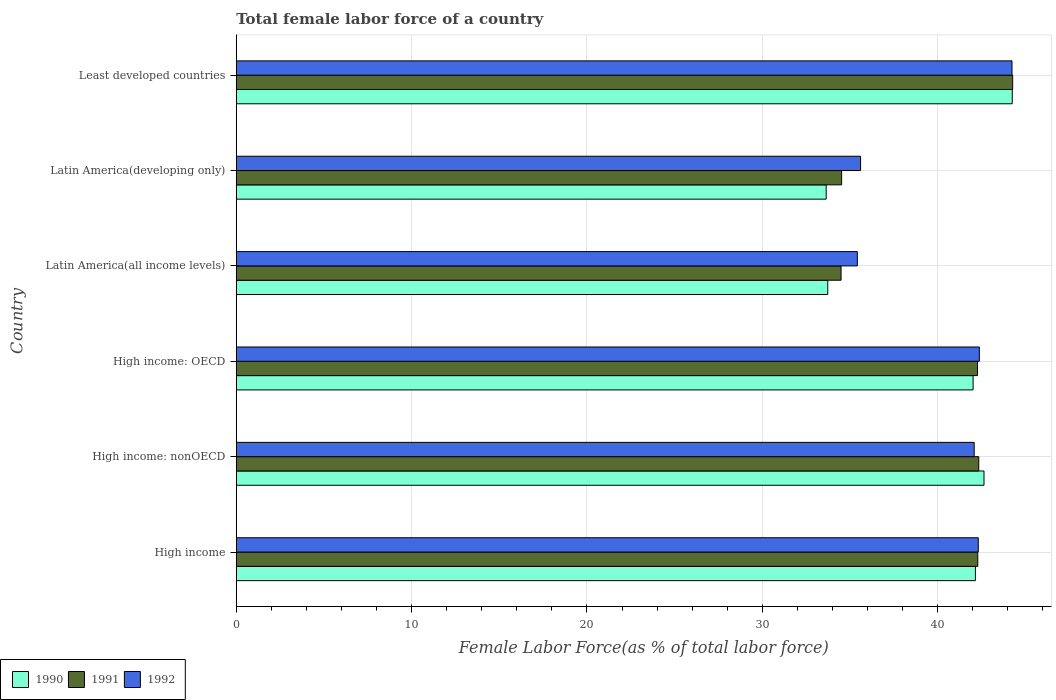Are the number of bars per tick equal to the number of legend labels?
Offer a terse response. Yes. Are the number of bars on each tick of the Y-axis equal?
Give a very brief answer. Yes. How many bars are there on the 6th tick from the top?
Your answer should be compact. 3. How many bars are there on the 6th tick from the bottom?
Make the answer very short. 3. What is the label of the 2nd group of bars from the top?
Keep it short and to the point. Latin America(developing only). In how many cases, is the number of bars for a given country not equal to the number of legend labels?
Give a very brief answer. 0. What is the percentage of female labor force in 1990 in Latin America(all income levels)?
Your response must be concise. 33.73. Across all countries, what is the maximum percentage of female labor force in 1992?
Offer a terse response. 44.24. Across all countries, what is the minimum percentage of female labor force in 1990?
Provide a short and direct response. 33.64. In which country was the percentage of female labor force in 1992 maximum?
Provide a succinct answer. Least developed countries. In which country was the percentage of female labor force in 1992 minimum?
Keep it short and to the point. Latin America(all income levels). What is the total percentage of female labor force in 1992 in the graph?
Your answer should be very brief. 242.04. What is the difference between the percentage of female labor force in 1992 in High income: nonOECD and that in Latin America(all income levels)?
Give a very brief answer. 6.66. What is the difference between the percentage of female labor force in 1992 in Latin America(developing only) and the percentage of female labor force in 1991 in Least developed countries?
Your response must be concise. -8.67. What is the average percentage of female labor force in 1990 per country?
Give a very brief answer. 39.74. What is the difference between the percentage of female labor force in 1992 and percentage of female labor force in 1991 in High income: OECD?
Keep it short and to the point. 0.11. In how many countries, is the percentage of female labor force in 1991 greater than 16 %?
Offer a terse response. 6. What is the ratio of the percentage of female labor force in 1992 in High income to that in Least developed countries?
Your answer should be very brief. 0.96. Is the percentage of female labor force in 1990 in High income: OECD less than that in Least developed countries?
Offer a very short reply. Yes. Is the difference between the percentage of female labor force in 1992 in High income: nonOECD and Latin America(developing only) greater than the difference between the percentage of female labor force in 1991 in High income: nonOECD and Latin America(developing only)?
Make the answer very short. No. What is the difference between the highest and the second highest percentage of female labor force in 1992?
Offer a terse response. 1.86. What is the difference between the highest and the lowest percentage of female labor force in 1991?
Offer a terse response. 9.79. What does the 1st bar from the top in High income: nonOECD represents?
Give a very brief answer. 1992. Is it the case that in every country, the sum of the percentage of female labor force in 1992 and percentage of female labor force in 1990 is greater than the percentage of female labor force in 1991?
Make the answer very short. Yes. Are all the bars in the graph horizontal?
Offer a terse response. Yes. How many countries are there in the graph?
Ensure brevity in your answer.  6. What is the difference between two consecutive major ticks on the X-axis?
Offer a terse response. 10. Are the values on the major ticks of X-axis written in scientific E-notation?
Your response must be concise. No. Does the graph contain any zero values?
Your answer should be very brief. No. How are the legend labels stacked?
Your answer should be compact. Horizontal. What is the title of the graph?
Ensure brevity in your answer.  Total female labor force of a country. Does "1972" appear as one of the legend labels in the graph?
Offer a very short reply. No. What is the label or title of the X-axis?
Your answer should be compact. Female Labor Force(as % of total labor force). What is the Female Labor Force(as % of total labor force) of 1990 in High income?
Your response must be concise. 42.15. What is the Female Labor Force(as % of total labor force) in 1991 in High income?
Make the answer very short. 42.29. What is the Female Labor Force(as % of total labor force) of 1992 in High income?
Offer a very short reply. 42.32. What is the Female Labor Force(as % of total labor force) in 1990 in High income: nonOECD?
Offer a very short reply. 42.64. What is the Female Labor Force(as % of total labor force) in 1991 in High income: nonOECD?
Make the answer very short. 42.34. What is the Female Labor Force(as % of total labor force) of 1992 in High income: nonOECD?
Ensure brevity in your answer.  42.08. What is the Female Labor Force(as % of total labor force) of 1990 in High income: OECD?
Your response must be concise. 42.02. What is the Female Labor Force(as % of total labor force) in 1991 in High income: OECD?
Your answer should be compact. 42.27. What is the Female Labor Force(as % of total labor force) of 1992 in High income: OECD?
Make the answer very short. 42.38. What is the Female Labor Force(as % of total labor force) in 1990 in Latin America(all income levels)?
Provide a short and direct response. 33.73. What is the Female Labor Force(as % of total labor force) in 1991 in Latin America(all income levels)?
Keep it short and to the point. 34.49. What is the Female Labor Force(as % of total labor force) of 1992 in Latin America(all income levels)?
Provide a succinct answer. 35.42. What is the Female Labor Force(as % of total labor force) of 1990 in Latin America(developing only)?
Provide a succinct answer. 33.64. What is the Female Labor Force(as % of total labor force) of 1991 in Latin America(developing only)?
Provide a succinct answer. 34.52. What is the Female Labor Force(as % of total labor force) in 1992 in Latin America(developing only)?
Make the answer very short. 35.6. What is the Female Labor Force(as % of total labor force) of 1990 in Least developed countries?
Your response must be concise. 44.25. What is the Female Labor Force(as % of total labor force) of 1991 in Least developed countries?
Give a very brief answer. 44.28. What is the Female Labor Force(as % of total labor force) in 1992 in Least developed countries?
Your response must be concise. 44.24. Across all countries, what is the maximum Female Labor Force(as % of total labor force) in 1990?
Make the answer very short. 44.25. Across all countries, what is the maximum Female Labor Force(as % of total labor force) of 1991?
Provide a succinct answer. 44.28. Across all countries, what is the maximum Female Labor Force(as % of total labor force) in 1992?
Make the answer very short. 44.24. Across all countries, what is the minimum Female Labor Force(as % of total labor force) of 1990?
Ensure brevity in your answer.  33.64. Across all countries, what is the minimum Female Labor Force(as % of total labor force) in 1991?
Give a very brief answer. 34.49. Across all countries, what is the minimum Female Labor Force(as % of total labor force) of 1992?
Provide a succinct answer. 35.42. What is the total Female Labor Force(as % of total labor force) in 1990 in the graph?
Ensure brevity in your answer.  238.45. What is the total Female Labor Force(as % of total labor force) in 1991 in the graph?
Provide a short and direct response. 240.19. What is the total Female Labor Force(as % of total labor force) of 1992 in the graph?
Your answer should be compact. 242.04. What is the difference between the Female Labor Force(as % of total labor force) of 1990 in High income and that in High income: nonOECD?
Ensure brevity in your answer.  -0.49. What is the difference between the Female Labor Force(as % of total labor force) in 1991 in High income and that in High income: nonOECD?
Give a very brief answer. -0.06. What is the difference between the Female Labor Force(as % of total labor force) in 1992 in High income and that in High income: nonOECD?
Your answer should be very brief. 0.23. What is the difference between the Female Labor Force(as % of total labor force) in 1990 in High income and that in High income: OECD?
Your answer should be very brief. 0.13. What is the difference between the Female Labor Force(as % of total labor force) in 1991 in High income and that in High income: OECD?
Keep it short and to the point. 0.01. What is the difference between the Female Labor Force(as % of total labor force) in 1992 in High income and that in High income: OECD?
Provide a succinct answer. -0.06. What is the difference between the Female Labor Force(as % of total labor force) in 1990 in High income and that in Latin America(all income levels)?
Your response must be concise. 8.42. What is the difference between the Female Labor Force(as % of total labor force) in 1991 in High income and that in Latin America(all income levels)?
Offer a terse response. 7.8. What is the difference between the Female Labor Force(as % of total labor force) of 1992 in High income and that in Latin America(all income levels)?
Your response must be concise. 6.9. What is the difference between the Female Labor Force(as % of total labor force) in 1990 in High income and that in Latin America(developing only)?
Keep it short and to the point. 8.51. What is the difference between the Female Labor Force(as % of total labor force) of 1991 in High income and that in Latin America(developing only)?
Make the answer very short. 7.76. What is the difference between the Female Labor Force(as % of total labor force) in 1992 in High income and that in Latin America(developing only)?
Your answer should be compact. 6.71. What is the difference between the Female Labor Force(as % of total labor force) in 1990 in High income and that in Least developed countries?
Give a very brief answer. -2.1. What is the difference between the Female Labor Force(as % of total labor force) in 1991 in High income and that in Least developed countries?
Offer a terse response. -1.99. What is the difference between the Female Labor Force(as % of total labor force) in 1992 in High income and that in Least developed countries?
Provide a succinct answer. -1.92. What is the difference between the Female Labor Force(as % of total labor force) in 1990 in High income: nonOECD and that in High income: OECD?
Your answer should be compact. 0.62. What is the difference between the Female Labor Force(as % of total labor force) in 1991 in High income: nonOECD and that in High income: OECD?
Keep it short and to the point. 0.07. What is the difference between the Female Labor Force(as % of total labor force) in 1992 in High income: nonOECD and that in High income: OECD?
Your answer should be compact. -0.29. What is the difference between the Female Labor Force(as % of total labor force) of 1990 in High income: nonOECD and that in Latin America(all income levels)?
Keep it short and to the point. 8.91. What is the difference between the Female Labor Force(as % of total labor force) in 1991 in High income: nonOECD and that in Latin America(all income levels)?
Your answer should be compact. 7.85. What is the difference between the Female Labor Force(as % of total labor force) in 1992 in High income: nonOECD and that in Latin America(all income levels)?
Your response must be concise. 6.66. What is the difference between the Female Labor Force(as % of total labor force) of 1990 in High income: nonOECD and that in Latin America(developing only)?
Your response must be concise. 9. What is the difference between the Female Labor Force(as % of total labor force) of 1991 in High income: nonOECD and that in Latin America(developing only)?
Keep it short and to the point. 7.82. What is the difference between the Female Labor Force(as % of total labor force) in 1992 in High income: nonOECD and that in Latin America(developing only)?
Offer a terse response. 6.48. What is the difference between the Female Labor Force(as % of total labor force) of 1990 in High income: nonOECD and that in Least developed countries?
Provide a succinct answer. -1.61. What is the difference between the Female Labor Force(as % of total labor force) in 1991 in High income: nonOECD and that in Least developed countries?
Your answer should be compact. -1.94. What is the difference between the Female Labor Force(as % of total labor force) in 1992 in High income: nonOECD and that in Least developed countries?
Your answer should be compact. -2.16. What is the difference between the Female Labor Force(as % of total labor force) of 1990 in High income: OECD and that in Latin America(all income levels)?
Offer a very short reply. 8.29. What is the difference between the Female Labor Force(as % of total labor force) of 1991 in High income: OECD and that in Latin America(all income levels)?
Your answer should be very brief. 7.78. What is the difference between the Female Labor Force(as % of total labor force) in 1992 in High income: OECD and that in Latin America(all income levels)?
Give a very brief answer. 6.96. What is the difference between the Female Labor Force(as % of total labor force) in 1990 in High income: OECD and that in Latin America(developing only)?
Provide a short and direct response. 8.38. What is the difference between the Female Labor Force(as % of total labor force) in 1991 in High income: OECD and that in Latin America(developing only)?
Ensure brevity in your answer.  7.75. What is the difference between the Female Labor Force(as % of total labor force) in 1992 in High income: OECD and that in Latin America(developing only)?
Keep it short and to the point. 6.77. What is the difference between the Female Labor Force(as % of total labor force) of 1990 in High income: OECD and that in Least developed countries?
Provide a short and direct response. -2.23. What is the difference between the Female Labor Force(as % of total labor force) in 1991 in High income: OECD and that in Least developed countries?
Provide a succinct answer. -2.01. What is the difference between the Female Labor Force(as % of total labor force) in 1992 in High income: OECD and that in Least developed countries?
Keep it short and to the point. -1.86. What is the difference between the Female Labor Force(as % of total labor force) in 1990 in Latin America(all income levels) and that in Latin America(developing only)?
Make the answer very short. 0.09. What is the difference between the Female Labor Force(as % of total labor force) in 1991 in Latin America(all income levels) and that in Latin America(developing only)?
Offer a very short reply. -0.03. What is the difference between the Female Labor Force(as % of total labor force) in 1992 in Latin America(all income levels) and that in Latin America(developing only)?
Your answer should be compact. -0.18. What is the difference between the Female Labor Force(as % of total labor force) in 1990 in Latin America(all income levels) and that in Least developed countries?
Your response must be concise. -10.52. What is the difference between the Female Labor Force(as % of total labor force) in 1991 in Latin America(all income levels) and that in Least developed countries?
Keep it short and to the point. -9.79. What is the difference between the Female Labor Force(as % of total labor force) of 1992 in Latin America(all income levels) and that in Least developed countries?
Your answer should be very brief. -8.82. What is the difference between the Female Labor Force(as % of total labor force) of 1990 in Latin America(developing only) and that in Least developed countries?
Offer a very short reply. -10.61. What is the difference between the Female Labor Force(as % of total labor force) in 1991 in Latin America(developing only) and that in Least developed countries?
Keep it short and to the point. -9.75. What is the difference between the Female Labor Force(as % of total labor force) in 1992 in Latin America(developing only) and that in Least developed countries?
Your response must be concise. -8.63. What is the difference between the Female Labor Force(as % of total labor force) of 1990 in High income and the Female Labor Force(as % of total labor force) of 1991 in High income: nonOECD?
Offer a terse response. -0.19. What is the difference between the Female Labor Force(as % of total labor force) in 1990 in High income and the Female Labor Force(as % of total labor force) in 1992 in High income: nonOECD?
Your answer should be compact. 0.07. What is the difference between the Female Labor Force(as % of total labor force) in 1991 in High income and the Female Labor Force(as % of total labor force) in 1992 in High income: nonOECD?
Keep it short and to the point. 0.2. What is the difference between the Female Labor Force(as % of total labor force) of 1990 in High income and the Female Labor Force(as % of total labor force) of 1991 in High income: OECD?
Provide a succinct answer. -0.12. What is the difference between the Female Labor Force(as % of total labor force) in 1990 in High income and the Female Labor Force(as % of total labor force) in 1992 in High income: OECD?
Keep it short and to the point. -0.23. What is the difference between the Female Labor Force(as % of total labor force) in 1991 in High income and the Female Labor Force(as % of total labor force) in 1992 in High income: OECD?
Offer a very short reply. -0.09. What is the difference between the Female Labor Force(as % of total labor force) in 1990 in High income and the Female Labor Force(as % of total labor force) in 1991 in Latin America(all income levels)?
Your response must be concise. 7.66. What is the difference between the Female Labor Force(as % of total labor force) in 1990 in High income and the Female Labor Force(as % of total labor force) in 1992 in Latin America(all income levels)?
Give a very brief answer. 6.73. What is the difference between the Female Labor Force(as % of total labor force) in 1991 in High income and the Female Labor Force(as % of total labor force) in 1992 in Latin America(all income levels)?
Provide a succinct answer. 6.87. What is the difference between the Female Labor Force(as % of total labor force) of 1990 in High income and the Female Labor Force(as % of total labor force) of 1991 in Latin America(developing only)?
Make the answer very short. 7.63. What is the difference between the Female Labor Force(as % of total labor force) of 1990 in High income and the Female Labor Force(as % of total labor force) of 1992 in Latin America(developing only)?
Keep it short and to the point. 6.55. What is the difference between the Female Labor Force(as % of total labor force) of 1991 in High income and the Female Labor Force(as % of total labor force) of 1992 in Latin America(developing only)?
Keep it short and to the point. 6.68. What is the difference between the Female Labor Force(as % of total labor force) in 1990 in High income and the Female Labor Force(as % of total labor force) in 1991 in Least developed countries?
Keep it short and to the point. -2.13. What is the difference between the Female Labor Force(as % of total labor force) of 1990 in High income and the Female Labor Force(as % of total labor force) of 1992 in Least developed countries?
Your answer should be very brief. -2.09. What is the difference between the Female Labor Force(as % of total labor force) in 1991 in High income and the Female Labor Force(as % of total labor force) in 1992 in Least developed countries?
Your answer should be compact. -1.95. What is the difference between the Female Labor Force(as % of total labor force) in 1990 in High income: nonOECD and the Female Labor Force(as % of total labor force) in 1991 in High income: OECD?
Give a very brief answer. 0.37. What is the difference between the Female Labor Force(as % of total labor force) in 1990 in High income: nonOECD and the Female Labor Force(as % of total labor force) in 1992 in High income: OECD?
Provide a short and direct response. 0.27. What is the difference between the Female Labor Force(as % of total labor force) in 1991 in High income: nonOECD and the Female Labor Force(as % of total labor force) in 1992 in High income: OECD?
Ensure brevity in your answer.  -0.04. What is the difference between the Female Labor Force(as % of total labor force) of 1990 in High income: nonOECD and the Female Labor Force(as % of total labor force) of 1991 in Latin America(all income levels)?
Your answer should be compact. 8.15. What is the difference between the Female Labor Force(as % of total labor force) of 1990 in High income: nonOECD and the Female Labor Force(as % of total labor force) of 1992 in Latin America(all income levels)?
Keep it short and to the point. 7.22. What is the difference between the Female Labor Force(as % of total labor force) of 1991 in High income: nonOECD and the Female Labor Force(as % of total labor force) of 1992 in Latin America(all income levels)?
Your answer should be compact. 6.92. What is the difference between the Female Labor Force(as % of total labor force) of 1990 in High income: nonOECD and the Female Labor Force(as % of total labor force) of 1991 in Latin America(developing only)?
Your answer should be compact. 8.12. What is the difference between the Female Labor Force(as % of total labor force) of 1990 in High income: nonOECD and the Female Labor Force(as % of total labor force) of 1992 in Latin America(developing only)?
Offer a terse response. 7.04. What is the difference between the Female Labor Force(as % of total labor force) in 1991 in High income: nonOECD and the Female Labor Force(as % of total labor force) in 1992 in Latin America(developing only)?
Your answer should be compact. 6.74. What is the difference between the Female Labor Force(as % of total labor force) in 1990 in High income: nonOECD and the Female Labor Force(as % of total labor force) in 1991 in Least developed countries?
Keep it short and to the point. -1.63. What is the difference between the Female Labor Force(as % of total labor force) of 1990 in High income: nonOECD and the Female Labor Force(as % of total labor force) of 1992 in Least developed countries?
Your answer should be very brief. -1.6. What is the difference between the Female Labor Force(as % of total labor force) of 1991 in High income: nonOECD and the Female Labor Force(as % of total labor force) of 1992 in Least developed countries?
Your answer should be compact. -1.9. What is the difference between the Female Labor Force(as % of total labor force) in 1990 in High income: OECD and the Female Labor Force(as % of total labor force) in 1991 in Latin America(all income levels)?
Your response must be concise. 7.53. What is the difference between the Female Labor Force(as % of total labor force) in 1990 in High income: OECD and the Female Labor Force(as % of total labor force) in 1992 in Latin America(all income levels)?
Your answer should be very brief. 6.6. What is the difference between the Female Labor Force(as % of total labor force) of 1991 in High income: OECD and the Female Labor Force(as % of total labor force) of 1992 in Latin America(all income levels)?
Your answer should be very brief. 6.85. What is the difference between the Female Labor Force(as % of total labor force) of 1990 in High income: OECD and the Female Labor Force(as % of total labor force) of 1991 in Latin America(developing only)?
Offer a terse response. 7.5. What is the difference between the Female Labor Force(as % of total labor force) in 1990 in High income: OECD and the Female Labor Force(as % of total labor force) in 1992 in Latin America(developing only)?
Your answer should be compact. 6.42. What is the difference between the Female Labor Force(as % of total labor force) in 1991 in High income: OECD and the Female Labor Force(as % of total labor force) in 1992 in Latin America(developing only)?
Offer a terse response. 6.67. What is the difference between the Female Labor Force(as % of total labor force) in 1990 in High income: OECD and the Female Labor Force(as % of total labor force) in 1991 in Least developed countries?
Offer a very short reply. -2.26. What is the difference between the Female Labor Force(as % of total labor force) of 1990 in High income: OECD and the Female Labor Force(as % of total labor force) of 1992 in Least developed countries?
Keep it short and to the point. -2.22. What is the difference between the Female Labor Force(as % of total labor force) in 1991 in High income: OECD and the Female Labor Force(as % of total labor force) in 1992 in Least developed countries?
Provide a short and direct response. -1.97. What is the difference between the Female Labor Force(as % of total labor force) in 1990 in Latin America(all income levels) and the Female Labor Force(as % of total labor force) in 1991 in Latin America(developing only)?
Offer a terse response. -0.79. What is the difference between the Female Labor Force(as % of total labor force) in 1990 in Latin America(all income levels) and the Female Labor Force(as % of total labor force) in 1992 in Latin America(developing only)?
Provide a succinct answer. -1.87. What is the difference between the Female Labor Force(as % of total labor force) of 1991 in Latin America(all income levels) and the Female Labor Force(as % of total labor force) of 1992 in Latin America(developing only)?
Offer a very short reply. -1.11. What is the difference between the Female Labor Force(as % of total labor force) of 1990 in Latin America(all income levels) and the Female Labor Force(as % of total labor force) of 1991 in Least developed countries?
Your answer should be very brief. -10.55. What is the difference between the Female Labor Force(as % of total labor force) of 1990 in Latin America(all income levels) and the Female Labor Force(as % of total labor force) of 1992 in Least developed countries?
Give a very brief answer. -10.51. What is the difference between the Female Labor Force(as % of total labor force) in 1991 in Latin America(all income levels) and the Female Labor Force(as % of total labor force) in 1992 in Least developed countries?
Offer a terse response. -9.75. What is the difference between the Female Labor Force(as % of total labor force) in 1990 in Latin America(developing only) and the Female Labor Force(as % of total labor force) in 1991 in Least developed countries?
Provide a short and direct response. -10.63. What is the difference between the Female Labor Force(as % of total labor force) of 1990 in Latin America(developing only) and the Female Labor Force(as % of total labor force) of 1992 in Least developed countries?
Keep it short and to the point. -10.6. What is the difference between the Female Labor Force(as % of total labor force) in 1991 in Latin America(developing only) and the Female Labor Force(as % of total labor force) in 1992 in Least developed countries?
Your answer should be compact. -9.72. What is the average Female Labor Force(as % of total labor force) in 1990 per country?
Offer a very short reply. 39.74. What is the average Female Labor Force(as % of total labor force) of 1991 per country?
Provide a short and direct response. 40.03. What is the average Female Labor Force(as % of total labor force) of 1992 per country?
Provide a succinct answer. 40.34. What is the difference between the Female Labor Force(as % of total labor force) in 1990 and Female Labor Force(as % of total labor force) in 1991 in High income?
Your answer should be very brief. -0.13. What is the difference between the Female Labor Force(as % of total labor force) of 1990 and Female Labor Force(as % of total labor force) of 1992 in High income?
Offer a very short reply. -0.16. What is the difference between the Female Labor Force(as % of total labor force) in 1991 and Female Labor Force(as % of total labor force) in 1992 in High income?
Provide a short and direct response. -0.03. What is the difference between the Female Labor Force(as % of total labor force) of 1990 and Female Labor Force(as % of total labor force) of 1991 in High income: nonOECD?
Provide a short and direct response. 0.3. What is the difference between the Female Labor Force(as % of total labor force) of 1990 and Female Labor Force(as % of total labor force) of 1992 in High income: nonOECD?
Make the answer very short. 0.56. What is the difference between the Female Labor Force(as % of total labor force) of 1991 and Female Labor Force(as % of total labor force) of 1992 in High income: nonOECD?
Provide a short and direct response. 0.26. What is the difference between the Female Labor Force(as % of total labor force) in 1990 and Female Labor Force(as % of total labor force) in 1991 in High income: OECD?
Make the answer very short. -0.25. What is the difference between the Female Labor Force(as % of total labor force) of 1990 and Female Labor Force(as % of total labor force) of 1992 in High income: OECD?
Offer a very short reply. -0.36. What is the difference between the Female Labor Force(as % of total labor force) in 1991 and Female Labor Force(as % of total labor force) in 1992 in High income: OECD?
Offer a terse response. -0.11. What is the difference between the Female Labor Force(as % of total labor force) of 1990 and Female Labor Force(as % of total labor force) of 1991 in Latin America(all income levels)?
Ensure brevity in your answer.  -0.76. What is the difference between the Female Labor Force(as % of total labor force) in 1990 and Female Labor Force(as % of total labor force) in 1992 in Latin America(all income levels)?
Your answer should be very brief. -1.69. What is the difference between the Female Labor Force(as % of total labor force) of 1991 and Female Labor Force(as % of total labor force) of 1992 in Latin America(all income levels)?
Make the answer very short. -0.93. What is the difference between the Female Labor Force(as % of total labor force) of 1990 and Female Labor Force(as % of total labor force) of 1991 in Latin America(developing only)?
Make the answer very short. -0.88. What is the difference between the Female Labor Force(as % of total labor force) of 1990 and Female Labor Force(as % of total labor force) of 1992 in Latin America(developing only)?
Make the answer very short. -1.96. What is the difference between the Female Labor Force(as % of total labor force) in 1991 and Female Labor Force(as % of total labor force) in 1992 in Latin America(developing only)?
Keep it short and to the point. -1.08. What is the difference between the Female Labor Force(as % of total labor force) of 1990 and Female Labor Force(as % of total labor force) of 1991 in Least developed countries?
Offer a very short reply. -0.02. What is the difference between the Female Labor Force(as % of total labor force) of 1990 and Female Labor Force(as % of total labor force) of 1992 in Least developed countries?
Provide a short and direct response. 0.01. What is the difference between the Female Labor Force(as % of total labor force) of 1991 and Female Labor Force(as % of total labor force) of 1992 in Least developed countries?
Your answer should be compact. 0.04. What is the ratio of the Female Labor Force(as % of total labor force) of 1990 in High income to that in High income: nonOECD?
Offer a terse response. 0.99. What is the ratio of the Female Labor Force(as % of total labor force) in 1992 in High income to that in High income: nonOECD?
Offer a terse response. 1.01. What is the ratio of the Female Labor Force(as % of total labor force) of 1990 in High income to that in High income: OECD?
Your response must be concise. 1. What is the ratio of the Female Labor Force(as % of total labor force) in 1990 in High income to that in Latin America(all income levels)?
Your answer should be very brief. 1.25. What is the ratio of the Female Labor Force(as % of total labor force) in 1991 in High income to that in Latin America(all income levels)?
Your answer should be compact. 1.23. What is the ratio of the Female Labor Force(as % of total labor force) of 1992 in High income to that in Latin America(all income levels)?
Ensure brevity in your answer.  1.19. What is the ratio of the Female Labor Force(as % of total labor force) in 1990 in High income to that in Latin America(developing only)?
Provide a succinct answer. 1.25. What is the ratio of the Female Labor Force(as % of total labor force) of 1991 in High income to that in Latin America(developing only)?
Offer a terse response. 1.22. What is the ratio of the Female Labor Force(as % of total labor force) of 1992 in High income to that in Latin America(developing only)?
Your response must be concise. 1.19. What is the ratio of the Female Labor Force(as % of total labor force) of 1990 in High income to that in Least developed countries?
Ensure brevity in your answer.  0.95. What is the ratio of the Female Labor Force(as % of total labor force) in 1991 in High income to that in Least developed countries?
Your response must be concise. 0.95. What is the ratio of the Female Labor Force(as % of total labor force) of 1992 in High income to that in Least developed countries?
Make the answer very short. 0.96. What is the ratio of the Female Labor Force(as % of total labor force) in 1990 in High income: nonOECD to that in High income: OECD?
Ensure brevity in your answer.  1.01. What is the ratio of the Female Labor Force(as % of total labor force) in 1991 in High income: nonOECD to that in High income: OECD?
Give a very brief answer. 1. What is the ratio of the Female Labor Force(as % of total labor force) in 1990 in High income: nonOECD to that in Latin America(all income levels)?
Offer a terse response. 1.26. What is the ratio of the Female Labor Force(as % of total labor force) in 1991 in High income: nonOECD to that in Latin America(all income levels)?
Offer a very short reply. 1.23. What is the ratio of the Female Labor Force(as % of total labor force) in 1992 in High income: nonOECD to that in Latin America(all income levels)?
Offer a terse response. 1.19. What is the ratio of the Female Labor Force(as % of total labor force) in 1990 in High income: nonOECD to that in Latin America(developing only)?
Offer a very short reply. 1.27. What is the ratio of the Female Labor Force(as % of total labor force) in 1991 in High income: nonOECD to that in Latin America(developing only)?
Offer a terse response. 1.23. What is the ratio of the Female Labor Force(as % of total labor force) of 1992 in High income: nonOECD to that in Latin America(developing only)?
Provide a succinct answer. 1.18. What is the ratio of the Female Labor Force(as % of total labor force) in 1990 in High income: nonOECD to that in Least developed countries?
Provide a short and direct response. 0.96. What is the ratio of the Female Labor Force(as % of total labor force) of 1991 in High income: nonOECD to that in Least developed countries?
Keep it short and to the point. 0.96. What is the ratio of the Female Labor Force(as % of total labor force) in 1992 in High income: nonOECD to that in Least developed countries?
Your response must be concise. 0.95. What is the ratio of the Female Labor Force(as % of total labor force) of 1990 in High income: OECD to that in Latin America(all income levels)?
Your answer should be compact. 1.25. What is the ratio of the Female Labor Force(as % of total labor force) in 1991 in High income: OECD to that in Latin America(all income levels)?
Keep it short and to the point. 1.23. What is the ratio of the Female Labor Force(as % of total labor force) of 1992 in High income: OECD to that in Latin America(all income levels)?
Your answer should be very brief. 1.2. What is the ratio of the Female Labor Force(as % of total labor force) in 1990 in High income: OECD to that in Latin America(developing only)?
Your answer should be very brief. 1.25. What is the ratio of the Female Labor Force(as % of total labor force) of 1991 in High income: OECD to that in Latin America(developing only)?
Your answer should be very brief. 1.22. What is the ratio of the Female Labor Force(as % of total labor force) in 1992 in High income: OECD to that in Latin America(developing only)?
Give a very brief answer. 1.19. What is the ratio of the Female Labor Force(as % of total labor force) in 1990 in High income: OECD to that in Least developed countries?
Your answer should be compact. 0.95. What is the ratio of the Female Labor Force(as % of total labor force) of 1991 in High income: OECD to that in Least developed countries?
Your answer should be very brief. 0.95. What is the ratio of the Female Labor Force(as % of total labor force) in 1992 in High income: OECD to that in Least developed countries?
Give a very brief answer. 0.96. What is the ratio of the Female Labor Force(as % of total labor force) in 1990 in Latin America(all income levels) to that in Latin America(developing only)?
Your answer should be compact. 1. What is the ratio of the Female Labor Force(as % of total labor force) in 1992 in Latin America(all income levels) to that in Latin America(developing only)?
Keep it short and to the point. 0.99. What is the ratio of the Female Labor Force(as % of total labor force) in 1990 in Latin America(all income levels) to that in Least developed countries?
Provide a succinct answer. 0.76. What is the ratio of the Female Labor Force(as % of total labor force) of 1991 in Latin America(all income levels) to that in Least developed countries?
Give a very brief answer. 0.78. What is the ratio of the Female Labor Force(as % of total labor force) of 1992 in Latin America(all income levels) to that in Least developed countries?
Your answer should be compact. 0.8. What is the ratio of the Female Labor Force(as % of total labor force) of 1990 in Latin America(developing only) to that in Least developed countries?
Your response must be concise. 0.76. What is the ratio of the Female Labor Force(as % of total labor force) in 1991 in Latin America(developing only) to that in Least developed countries?
Provide a succinct answer. 0.78. What is the ratio of the Female Labor Force(as % of total labor force) in 1992 in Latin America(developing only) to that in Least developed countries?
Keep it short and to the point. 0.8. What is the difference between the highest and the second highest Female Labor Force(as % of total labor force) of 1990?
Provide a short and direct response. 1.61. What is the difference between the highest and the second highest Female Labor Force(as % of total labor force) in 1991?
Your answer should be compact. 1.94. What is the difference between the highest and the second highest Female Labor Force(as % of total labor force) of 1992?
Give a very brief answer. 1.86. What is the difference between the highest and the lowest Female Labor Force(as % of total labor force) of 1990?
Your answer should be very brief. 10.61. What is the difference between the highest and the lowest Female Labor Force(as % of total labor force) in 1991?
Your answer should be compact. 9.79. What is the difference between the highest and the lowest Female Labor Force(as % of total labor force) of 1992?
Make the answer very short. 8.82. 